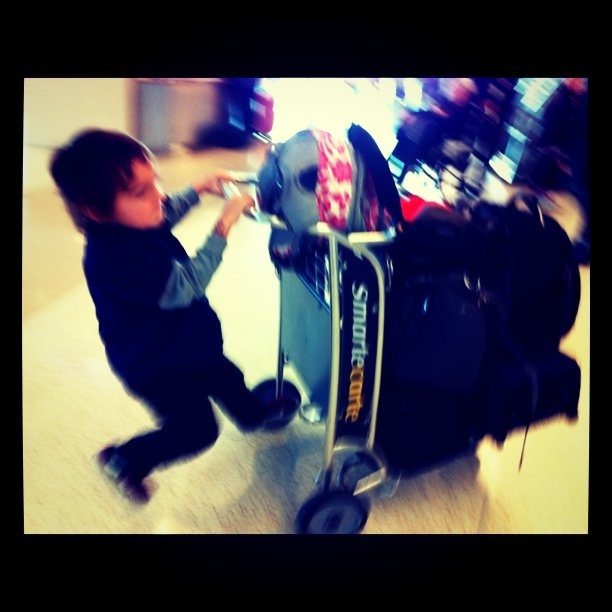Describe the objects in this image and their specific colors. I can see people in black, navy, khaki, and salmon tones, suitcase in black, navy, darkgray, and gray tones, and backpack in black, navy, beige, darkgray, and gray tones in this image. 